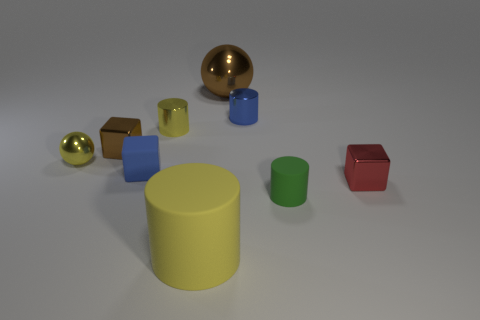Subtract all tiny metallic cubes. How many cubes are left? 1 Subtract all gray blocks. How many yellow cylinders are left? 2 Add 1 large brown rubber cylinders. How many objects exist? 10 Subtract all blue blocks. How many blocks are left? 2 Subtract 2 cylinders. How many cylinders are left? 2 Subtract all cubes. How many objects are left? 6 Subtract all brown spheres. Subtract all blue cylinders. How many spheres are left? 1 Subtract all big purple rubber cylinders. Subtract all tiny red metal cubes. How many objects are left? 8 Add 7 large metallic objects. How many large metallic objects are left? 8 Add 5 small blue rubber blocks. How many small blue rubber blocks exist? 6 